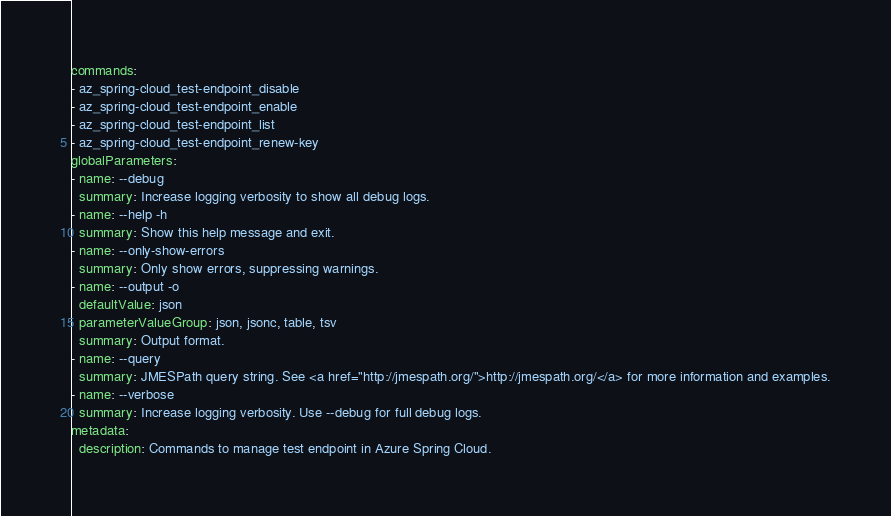<code> <loc_0><loc_0><loc_500><loc_500><_YAML_>commands:
- az_spring-cloud_test-endpoint_disable
- az_spring-cloud_test-endpoint_enable
- az_spring-cloud_test-endpoint_list
- az_spring-cloud_test-endpoint_renew-key
globalParameters:
- name: --debug
  summary: Increase logging verbosity to show all debug logs.
- name: --help -h
  summary: Show this help message and exit.
- name: --only-show-errors
  summary: Only show errors, suppressing warnings.
- name: --output -o
  defaultValue: json
  parameterValueGroup: json, jsonc, table, tsv
  summary: Output format.
- name: --query
  summary: JMESPath query string. See <a href="http://jmespath.org/">http://jmespath.org/</a> for more information and examples.
- name: --verbose
  summary: Increase logging verbosity. Use --debug for full debug logs.
metadata:
  description: Commands to manage test endpoint in Azure Spring Cloud.
</code> 